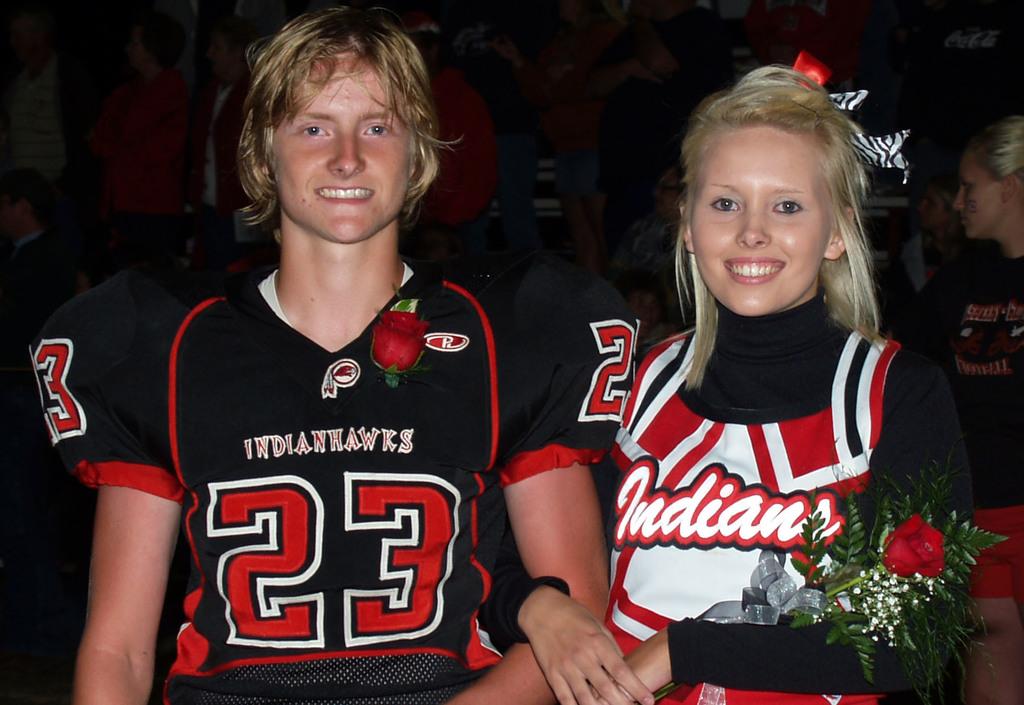What is the name of the team?
Make the answer very short. Indians. 